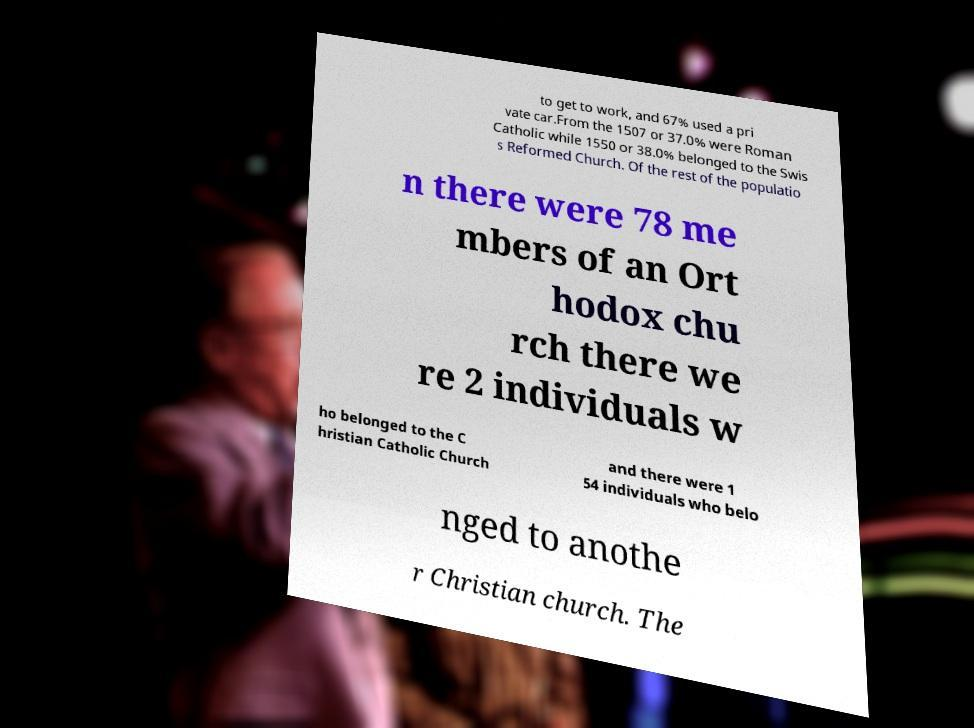What messages or text are displayed in this image? I need them in a readable, typed format. to get to work, and 67% used a pri vate car.From the 1507 or 37.0% were Roman Catholic while 1550 or 38.0% belonged to the Swis s Reformed Church. Of the rest of the populatio n there were 78 me mbers of an Ort hodox chu rch there we re 2 individuals w ho belonged to the C hristian Catholic Church and there were 1 54 individuals who belo nged to anothe r Christian church. The 